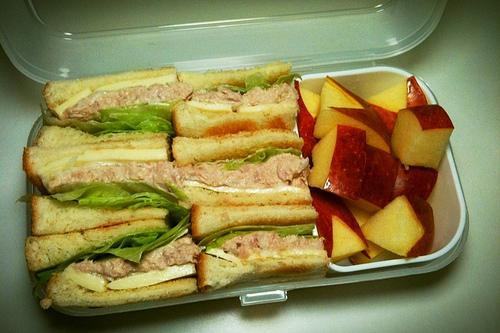What food is with the pickles?
Concise answer only. Tuna. What fruit is depicted?
Give a very brief answer. Apple. How many pieces of sandwich are in the photo?
Be succinct. 6. Is this enough food for two people?
Concise answer only. Yes. 